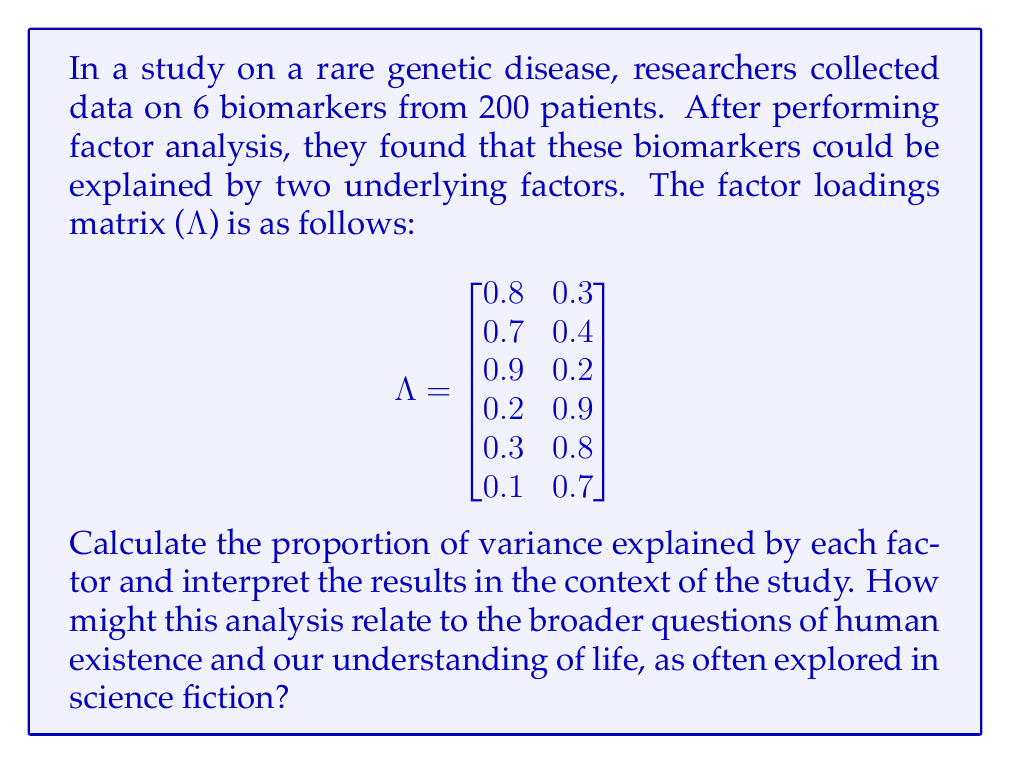Could you help me with this problem? To solve this problem, we'll follow these steps:

1. Calculate the communalities for each biomarker
2. Sum the communalities to get the total variance explained
3. Calculate the proportion of variance explained by each factor
4. Interpret the results

Step 1: Calculate the communalities

The communality for each biomarker is the sum of squared factor loadings across all factors. For biomarker i:

$h_i^2 = \sum_{j=1}^k \lambda_{ij}^2$

Where $k$ is the number of factors (2 in this case).

For biomarker 1: $h_1^2 = 0.8^2 + 0.3^2 = 0.64 + 0.09 = 0.73$
For biomarker 2: $h_2^2 = 0.7^2 + 0.4^2 = 0.49 + 0.16 = 0.65$
For biomarker 3: $h_3^2 = 0.9^2 + 0.2^2 = 0.81 + 0.04 = 0.85$
For biomarker 4: $h_4^2 = 0.2^2 + 0.9^2 = 0.04 + 0.81 = 0.85$
For biomarker 5: $h_5^2 = 0.3^2 + 0.8^2 = 0.09 + 0.64 = 0.73$
For biomarker 6: $h_6^2 = 0.1^2 + 0.7^2 = 0.01 + 0.49 = 0.50$

Step 2: Sum the communalities

Total variance explained = $\sum_{i=1}^6 h_i^2 = 0.73 + 0.65 + 0.85 + 0.85 + 0.73 + 0.50 = 4.31$

Step 3: Calculate the proportion of variance explained by each factor

For factor j: $\text{Proportion}_j = \frac{\sum_{i=1}^6 \lambda_{ij}^2}{\text{Total variance explained}}$

For factor 1: $\frac{0.8^2 + 0.7^2 + 0.9^2 + 0.2^2 + 0.3^2 + 0.1^2}{4.31} = \frac{2.08}{4.31} = 0.4827$ or 48.27%

For factor 2: $\frac{0.3^2 + 0.4^2 + 0.2^2 + 0.9^2 + 0.8^2 + 0.7^2}{4.31} = \frac{2.23}{4.31} = 0.5173$ or 51.73%

Step 4: Interpret the results

The two factors explain a total of 4.31 out of 6 possible variance units (72.17% of the total variance). Factor 1 explains 48.27% of the total variance, while Factor 2 explains 51.73%.

In the context of the study, this suggests that the six biomarkers can be effectively reduced to two underlying factors, which together explain a large proportion of the variability in the data. Factor 1 seems to be more strongly associated with the first three biomarkers, while Factor 2 is more strongly associated with the last three biomarkers.

Relating this to broader existential questions and science fiction themes:
1. The reduction of complex biological data to simpler underlying factors mirrors the search for fundamental laws or principles governing life and the universe.
2. The interplay between multiple biomarkers and their underlying factors reflects the interconnectedness of biological systems, a theme often explored in science fiction when considering the nature of life and consciousness.
3. The ability to uncover hidden patterns in biological data raises questions about determinism and free will, common topics in both metaphysics and science fiction.
4. The simplification of complex systems through statistical analysis parallels the scientific pursuit of unifying theories, a concept frequently addressed in science fiction narratives about understanding the universe.
Answer: Factor 1 explains 48.27% of the total variance, and Factor 2 explains 51.73% of the total variance. Together, they account for 72.17% of the total variance in the six biomarkers. 